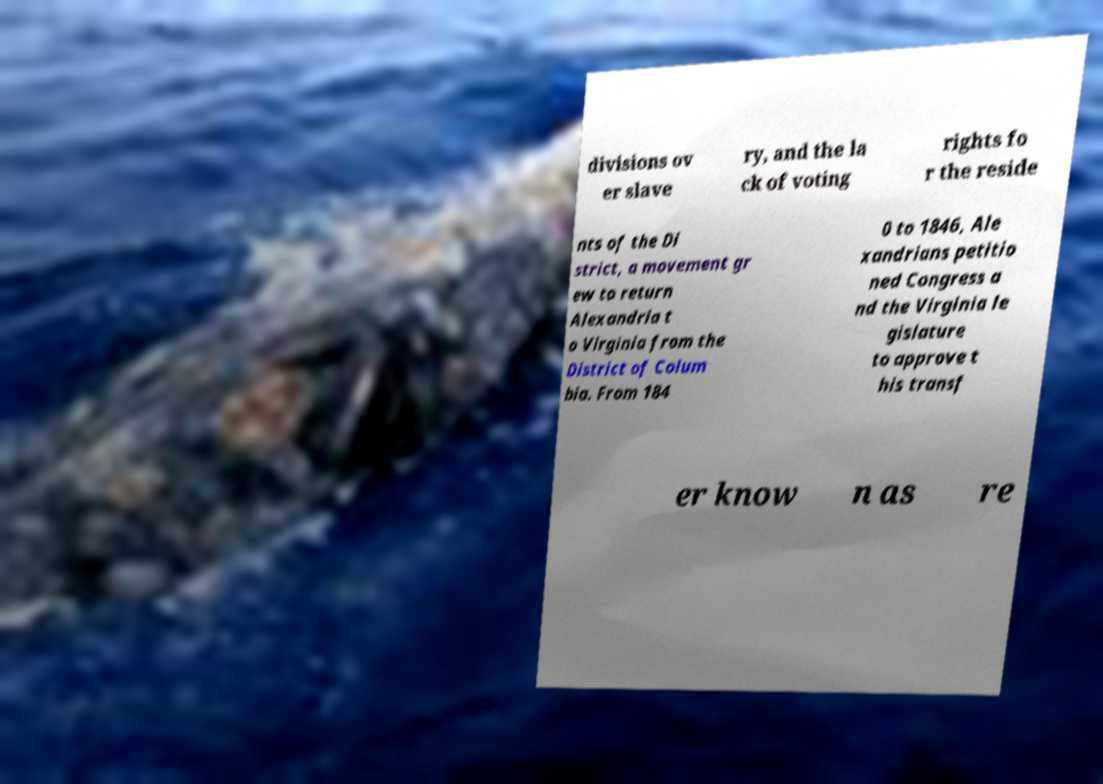Could you assist in decoding the text presented in this image and type it out clearly? divisions ov er slave ry, and the la ck of voting rights fo r the reside nts of the Di strict, a movement gr ew to return Alexandria t o Virginia from the District of Colum bia. From 184 0 to 1846, Ale xandrians petitio ned Congress a nd the Virginia le gislature to approve t his transf er know n as re 